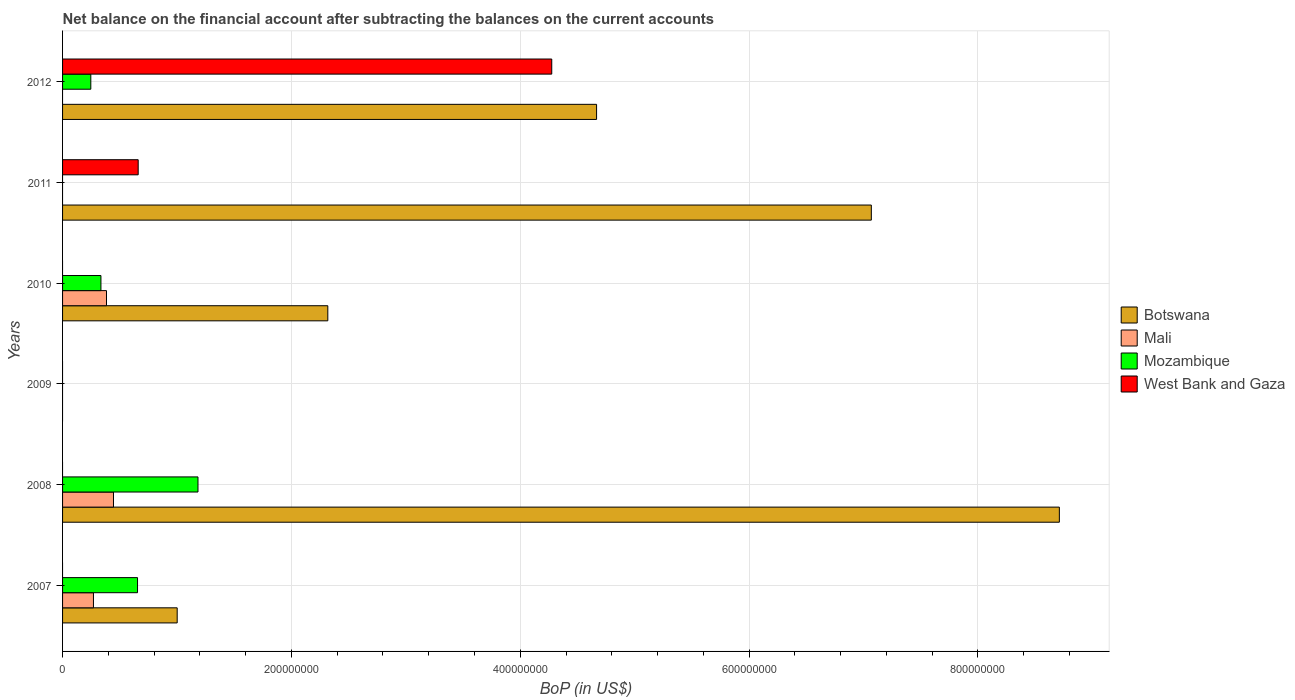Are the number of bars on each tick of the Y-axis equal?
Keep it short and to the point. No. How many bars are there on the 3rd tick from the top?
Your answer should be compact. 3. What is the Balance of Payments in Mozambique in 2009?
Make the answer very short. 0. Across all years, what is the maximum Balance of Payments in Mali?
Provide a succinct answer. 4.45e+07. In which year was the Balance of Payments in Mali maximum?
Provide a succinct answer. 2008. What is the total Balance of Payments in Mozambique in the graph?
Your answer should be compact. 2.42e+08. What is the difference between the Balance of Payments in Botswana in 2008 and that in 2010?
Keep it short and to the point. 6.39e+08. What is the difference between the Balance of Payments in Mali in 2011 and the Balance of Payments in Botswana in 2007?
Keep it short and to the point. -1.00e+08. What is the average Balance of Payments in Mozambique per year?
Offer a very short reply. 4.03e+07. In the year 2012, what is the difference between the Balance of Payments in West Bank and Gaza and Balance of Payments in Mozambique?
Make the answer very short. 4.03e+08. What is the ratio of the Balance of Payments in Botswana in 2010 to that in 2011?
Make the answer very short. 0.33. What is the difference between the highest and the second highest Balance of Payments in Mozambique?
Offer a terse response. 5.28e+07. What is the difference between the highest and the lowest Balance of Payments in Mali?
Give a very brief answer. 4.45e+07. In how many years, is the Balance of Payments in Botswana greater than the average Balance of Payments in Botswana taken over all years?
Ensure brevity in your answer.  3. Is the sum of the Balance of Payments in Mali in 2007 and 2010 greater than the maximum Balance of Payments in Botswana across all years?
Provide a short and direct response. No. How many bars are there?
Offer a terse response. 14. Are all the bars in the graph horizontal?
Make the answer very short. Yes. How many years are there in the graph?
Keep it short and to the point. 6. What is the difference between two consecutive major ticks on the X-axis?
Make the answer very short. 2.00e+08. Where does the legend appear in the graph?
Provide a short and direct response. Center right. How many legend labels are there?
Make the answer very short. 4. How are the legend labels stacked?
Your answer should be very brief. Vertical. What is the title of the graph?
Ensure brevity in your answer.  Net balance on the financial account after subtracting the balances on the current accounts. What is the label or title of the X-axis?
Provide a short and direct response. BoP (in US$). What is the BoP (in US$) in Botswana in 2007?
Offer a very short reply. 1.00e+08. What is the BoP (in US$) of Mali in 2007?
Your response must be concise. 2.70e+07. What is the BoP (in US$) of Mozambique in 2007?
Offer a terse response. 6.55e+07. What is the BoP (in US$) of West Bank and Gaza in 2007?
Make the answer very short. 0. What is the BoP (in US$) in Botswana in 2008?
Keep it short and to the point. 8.71e+08. What is the BoP (in US$) of Mali in 2008?
Give a very brief answer. 4.45e+07. What is the BoP (in US$) in Mozambique in 2008?
Ensure brevity in your answer.  1.18e+08. What is the BoP (in US$) of West Bank and Gaza in 2009?
Ensure brevity in your answer.  0. What is the BoP (in US$) of Botswana in 2010?
Offer a very short reply. 2.32e+08. What is the BoP (in US$) of Mali in 2010?
Keep it short and to the point. 3.84e+07. What is the BoP (in US$) of Mozambique in 2010?
Offer a very short reply. 3.35e+07. What is the BoP (in US$) of Botswana in 2011?
Offer a terse response. 7.07e+08. What is the BoP (in US$) of Mali in 2011?
Make the answer very short. 0. What is the BoP (in US$) in Mozambique in 2011?
Make the answer very short. 0. What is the BoP (in US$) of West Bank and Gaza in 2011?
Your response must be concise. 6.61e+07. What is the BoP (in US$) in Botswana in 2012?
Provide a succinct answer. 4.67e+08. What is the BoP (in US$) of Mozambique in 2012?
Your answer should be very brief. 2.47e+07. What is the BoP (in US$) of West Bank and Gaza in 2012?
Ensure brevity in your answer.  4.28e+08. Across all years, what is the maximum BoP (in US$) in Botswana?
Ensure brevity in your answer.  8.71e+08. Across all years, what is the maximum BoP (in US$) of Mali?
Provide a succinct answer. 4.45e+07. Across all years, what is the maximum BoP (in US$) in Mozambique?
Give a very brief answer. 1.18e+08. Across all years, what is the maximum BoP (in US$) of West Bank and Gaza?
Make the answer very short. 4.28e+08. Across all years, what is the minimum BoP (in US$) in Botswana?
Your response must be concise. 0. Across all years, what is the minimum BoP (in US$) in Mali?
Keep it short and to the point. 0. Across all years, what is the minimum BoP (in US$) in Mozambique?
Your response must be concise. 0. Across all years, what is the minimum BoP (in US$) in West Bank and Gaza?
Give a very brief answer. 0. What is the total BoP (in US$) of Botswana in the graph?
Offer a very short reply. 2.38e+09. What is the total BoP (in US$) in Mali in the graph?
Your answer should be very brief. 1.10e+08. What is the total BoP (in US$) of Mozambique in the graph?
Provide a succinct answer. 2.42e+08. What is the total BoP (in US$) in West Bank and Gaza in the graph?
Provide a short and direct response. 4.94e+08. What is the difference between the BoP (in US$) in Botswana in 2007 and that in 2008?
Offer a terse response. -7.71e+08. What is the difference between the BoP (in US$) of Mali in 2007 and that in 2008?
Offer a terse response. -1.75e+07. What is the difference between the BoP (in US$) of Mozambique in 2007 and that in 2008?
Your response must be concise. -5.28e+07. What is the difference between the BoP (in US$) of Botswana in 2007 and that in 2010?
Ensure brevity in your answer.  -1.32e+08. What is the difference between the BoP (in US$) in Mali in 2007 and that in 2010?
Your answer should be compact. -1.14e+07. What is the difference between the BoP (in US$) in Mozambique in 2007 and that in 2010?
Make the answer very short. 3.20e+07. What is the difference between the BoP (in US$) in Botswana in 2007 and that in 2011?
Make the answer very short. -6.07e+08. What is the difference between the BoP (in US$) in Botswana in 2007 and that in 2012?
Offer a terse response. -3.67e+08. What is the difference between the BoP (in US$) in Mozambique in 2007 and that in 2012?
Keep it short and to the point. 4.08e+07. What is the difference between the BoP (in US$) in Botswana in 2008 and that in 2010?
Provide a short and direct response. 6.39e+08. What is the difference between the BoP (in US$) in Mali in 2008 and that in 2010?
Give a very brief answer. 6.10e+06. What is the difference between the BoP (in US$) of Mozambique in 2008 and that in 2010?
Your response must be concise. 8.48e+07. What is the difference between the BoP (in US$) in Botswana in 2008 and that in 2011?
Your answer should be very brief. 1.64e+08. What is the difference between the BoP (in US$) of Botswana in 2008 and that in 2012?
Give a very brief answer. 4.04e+08. What is the difference between the BoP (in US$) of Mozambique in 2008 and that in 2012?
Ensure brevity in your answer.  9.37e+07. What is the difference between the BoP (in US$) of Botswana in 2010 and that in 2011?
Ensure brevity in your answer.  -4.75e+08. What is the difference between the BoP (in US$) of Botswana in 2010 and that in 2012?
Give a very brief answer. -2.35e+08. What is the difference between the BoP (in US$) in Mozambique in 2010 and that in 2012?
Keep it short and to the point. 8.85e+06. What is the difference between the BoP (in US$) of Botswana in 2011 and that in 2012?
Offer a very short reply. 2.40e+08. What is the difference between the BoP (in US$) in West Bank and Gaza in 2011 and that in 2012?
Your response must be concise. -3.61e+08. What is the difference between the BoP (in US$) of Botswana in 2007 and the BoP (in US$) of Mali in 2008?
Keep it short and to the point. 5.57e+07. What is the difference between the BoP (in US$) in Botswana in 2007 and the BoP (in US$) in Mozambique in 2008?
Make the answer very short. -1.82e+07. What is the difference between the BoP (in US$) of Mali in 2007 and the BoP (in US$) of Mozambique in 2008?
Offer a terse response. -9.14e+07. What is the difference between the BoP (in US$) of Botswana in 2007 and the BoP (in US$) of Mali in 2010?
Ensure brevity in your answer.  6.18e+07. What is the difference between the BoP (in US$) of Botswana in 2007 and the BoP (in US$) of Mozambique in 2010?
Ensure brevity in your answer.  6.66e+07. What is the difference between the BoP (in US$) in Mali in 2007 and the BoP (in US$) in Mozambique in 2010?
Provide a short and direct response. -6.53e+06. What is the difference between the BoP (in US$) of Botswana in 2007 and the BoP (in US$) of West Bank and Gaza in 2011?
Offer a terse response. 3.41e+07. What is the difference between the BoP (in US$) of Mali in 2007 and the BoP (in US$) of West Bank and Gaza in 2011?
Provide a succinct answer. -3.91e+07. What is the difference between the BoP (in US$) of Mozambique in 2007 and the BoP (in US$) of West Bank and Gaza in 2011?
Your answer should be compact. -5.82e+05. What is the difference between the BoP (in US$) in Botswana in 2007 and the BoP (in US$) in Mozambique in 2012?
Offer a very short reply. 7.55e+07. What is the difference between the BoP (in US$) of Botswana in 2007 and the BoP (in US$) of West Bank and Gaza in 2012?
Your response must be concise. -3.27e+08. What is the difference between the BoP (in US$) in Mali in 2007 and the BoP (in US$) in Mozambique in 2012?
Make the answer very short. 2.31e+06. What is the difference between the BoP (in US$) in Mali in 2007 and the BoP (in US$) in West Bank and Gaza in 2012?
Your answer should be very brief. -4.01e+08. What is the difference between the BoP (in US$) of Mozambique in 2007 and the BoP (in US$) of West Bank and Gaza in 2012?
Ensure brevity in your answer.  -3.62e+08. What is the difference between the BoP (in US$) in Botswana in 2008 and the BoP (in US$) in Mali in 2010?
Your answer should be very brief. 8.33e+08. What is the difference between the BoP (in US$) of Botswana in 2008 and the BoP (in US$) of Mozambique in 2010?
Your answer should be compact. 8.38e+08. What is the difference between the BoP (in US$) in Mali in 2008 and the BoP (in US$) in Mozambique in 2010?
Keep it short and to the point. 1.10e+07. What is the difference between the BoP (in US$) in Botswana in 2008 and the BoP (in US$) in West Bank and Gaza in 2011?
Make the answer very short. 8.05e+08. What is the difference between the BoP (in US$) of Mali in 2008 and the BoP (in US$) of West Bank and Gaza in 2011?
Your answer should be compact. -2.16e+07. What is the difference between the BoP (in US$) of Mozambique in 2008 and the BoP (in US$) of West Bank and Gaza in 2011?
Your response must be concise. 5.23e+07. What is the difference between the BoP (in US$) in Botswana in 2008 and the BoP (in US$) in Mozambique in 2012?
Provide a succinct answer. 8.46e+08. What is the difference between the BoP (in US$) in Botswana in 2008 and the BoP (in US$) in West Bank and Gaza in 2012?
Your answer should be compact. 4.44e+08. What is the difference between the BoP (in US$) in Mali in 2008 and the BoP (in US$) in Mozambique in 2012?
Your response must be concise. 1.98e+07. What is the difference between the BoP (in US$) of Mali in 2008 and the BoP (in US$) of West Bank and Gaza in 2012?
Offer a terse response. -3.83e+08. What is the difference between the BoP (in US$) of Mozambique in 2008 and the BoP (in US$) of West Bank and Gaza in 2012?
Your response must be concise. -3.09e+08. What is the difference between the BoP (in US$) in Botswana in 2010 and the BoP (in US$) in West Bank and Gaza in 2011?
Provide a short and direct response. 1.66e+08. What is the difference between the BoP (in US$) in Mali in 2010 and the BoP (in US$) in West Bank and Gaza in 2011?
Offer a very short reply. -2.77e+07. What is the difference between the BoP (in US$) in Mozambique in 2010 and the BoP (in US$) in West Bank and Gaza in 2011?
Provide a short and direct response. -3.26e+07. What is the difference between the BoP (in US$) of Botswana in 2010 and the BoP (in US$) of Mozambique in 2012?
Provide a short and direct response. 2.07e+08. What is the difference between the BoP (in US$) of Botswana in 2010 and the BoP (in US$) of West Bank and Gaza in 2012?
Provide a short and direct response. -1.96e+08. What is the difference between the BoP (in US$) of Mali in 2010 and the BoP (in US$) of Mozambique in 2012?
Keep it short and to the point. 1.37e+07. What is the difference between the BoP (in US$) of Mali in 2010 and the BoP (in US$) of West Bank and Gaza in 2012?
Make the answer very short. -3.89e+08. What is the difference between the BoP (in US$) in Mozambique in 2010 and the BoP (in US$) in West Bank and Gaza in 2012?
Your response must be concise. -3.94e+08. What is the difference between the BoP (in US$) of Botswana in 2011 and the BoP (in US$) of Mozambique in 2012?
Make the answer very short. 6.82e+08. What is the difference between the BoP (in US$) of Botswana in 2011 and the BoP (in US$) of West Bank and Gaza in 2012?
Your response must be concise. 2.79e+08. What is the average BoP (in US$) of Botswana per year?
Your answer should be very brief. 3.96e+08. What is the average BoP (in US$) in Mali per year?
Your answer should be compact. 1.83e+07. What is the average BoP (in US$) of Mozambique per year?
Your answer should be very brief. 4.03e+07. What is the average BoP (in US$) of West Bank and Gaza per year?
Make the answer very short. 8.23e+07. In the year 2007, what is the difference between the BoP (in US$) of Botswana and BoP (in US$) of Mali?
Ensure brevity in your answer.  7.32e+07. In the year 2007, what is the difference between the BoP (in US$) in Botswana and BoP (in US$) in Mozambique?
Your response must be concise. 3.47e+07. In the year 2007, what is the difference between the BoP (in US$) of Mali and BoP (in US$) of Mozambique?
Give a very brief answer. -3.85e+07. In the year 2008, what is the difference between the BoP (in US$) in Botswana and BoP (in US$) in Mali?
Offer a terse response. 8.27e+08. In the year 2008, what is the difference between the BoP (in US$) in Botswana and BoP (in US$) in Mozambique?
Provide a succinct answer. 7.53e+08. In the year 2008, what is the difference between the BoP (in US$) in Mali and BoP (in US$) in Mozambique?
Offer a terse response. -7.38e+07. In the year 2010, what is the difference between the BoP (in US$) of Botswana and BoP (in US$) of Mali?
Make the answer very short. 1.93e+08. In the year 2010, what is the difference between the BoP (in US$) in Botswana and BoP (in US$) in Mozambique?
Ensure brevity in your answer.  1.98e+08. In the year 2010, what is the difference between the BoP (in US$) of Mali and BoP (in US$) of Mozambique?
Your response must be concise. 4.87e+06. In the year 2011, what is the difference between the BoP (in US$) in Botswana and BoP (in US$) in West Bank and Gaza?
Offer a very short reply. 6.41e+08. In the year 2012, what is the difference between the BoP (in US$) of Botswana and BoP (in US$) of Mozambique?
Your response must be concise. 4.42e+08. In the year 2012, what is the difference between the BoP (in US$) of Botswana and BoP (in US$) of West Bank and Gaza?
Your response must be concise. 3.92e+07. In the year 2012, what is the difference between the BoP (in US$) in Mozambique and BoP (in US$) in West Bank and Gaza?
Make the answer very short. -4.03e+08. What is the ratio of the BoP (in US$) of Botswana in 2007 to that in 2008?
Your answer should be compact. 0.12. What is the ratio of the BoP (in US$) of Mali in 2007 to that in 2008?
Give a very brief answer. 0.61. What is the ratio of the BoP (in US$) in Mozambique in 2007 to that in 2008?
Give a very brief answer. 0.55. What is the ratio of the BoP (in US$) in Botswana in 2007 to that in 2010?
Provide a succinct answer. 0.43. What is the ratio of the BoP (in US$) of Mali in 2007 to that in 2010?
Your answer should be very brief. 0.7. What is the ratio of the BoP (in US$) of Mozambique in 2007 to that in 2010?
Your answer should be compact. 1.95. What is the ratio of the BoP (in US$) of Botswana in 2007 to that in 2011?
Your response must be concise. 0.14. What is the ratio of the BoP (in US$) of Botswana in 2007 to that in 2012?
Make the answer very short. 0.21. What is the ratio of the BoP (in US$) in Mozambique in 2007 to that in 2012?
Offer a very short reply. 2.65. What is the ratio of the BoP (in US$) of Botswana in 2008 to that in 2010?
Your answer should be compact. 3.76. What is the ratio of the BoP (in US$) of Mali in 2008 to that in 2010?
Provide a succinct answer. 1.16. What is the ratio of the BoP (in US$) of Mozambique in 2008 to that in 2010?
Give a very brief answer. 3.53. What is the ratio of the BoP (in US$) in Botswana in 2008 to that in 2011?
Your answer should be very brief. 1.23. What is the ratio of the BoP (in US$) of Botswana in 2008 to that in 2012?
Keep it short and to the point. 1.87. What is the ratio of the BoP (in US$) of Mozambique in 2008 to that in 2012?
Your answer should be compact. 4.79. What is the ratio of the BoP (in US$) of Botswana in 2010 to that in 2011?
Make the answer very short. 0.33. What is the ratio of the BoP (in US$) of Botswana in 2010 to that in 2012?
Ensure brevity in your answer.  0.5. What is the ratio of the BoP (in US$) of Mozambique in 2010 to that in 2012?
Offer a terse response. 1.36. What is the ratio of the BoP (in US$) of Botswana in 2011 to that in 2012?
Ensure brevity in your answer.  1.51. What is the ratio of the BoP (in US$) of West Bank and Gaza in 2011 to that in 2012?
Keep it short and to the point. 0.15. What is the difference between the highest and the second highest BoP (in US$) in Botswana?
Keep it short and to the point. 1.64e+08. What is the difference between the highest and the second highest BoP (in US$) in Mali?
Offer a terse response. 6.10e+06. What is the difference between the highest and the second highest BoP (in US$) of Mozambique?
Provide a succinct answer. 5.28e+07. What is the difference between the highest and the lowest BoP (in US$) of Botswana?
Ensure brevity in your answer.  8.71e+08. What is the difference between the highest and the lowest BoP (in US$) in Mali?
Your answer should be compact. 4.45e+07. What is the difference between the highest and the lowest BoP (in US$) of Mozambique?
Your answer should be compact. 1.18e+08. What is the difference between the highest and the lowest BoP (in US$) in West Bank and Gaza?
Your answer should be very brief. 4.28e+08. 